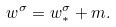Convert formula to latex. <formula><loc_0><loc_0><loc_500><loc_500>w ^ { \sigma } = w _ { * } ^ { \sigma } + m .</formula> 